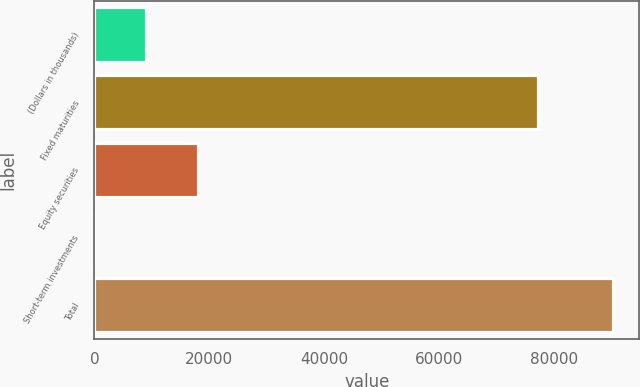<chart> <loc_0><loc_0><loc_500><loc_500><bar_chart><fcel>(Dollars in thousands)<fcel>Fixed maturities<fcel>Equity securities<fcel>Short-term investments<fcel>Total<nl><fcel>9029.3<fcel>77242<fcel>18057.6<fcel>1<fcel>90284<nl></chart> 